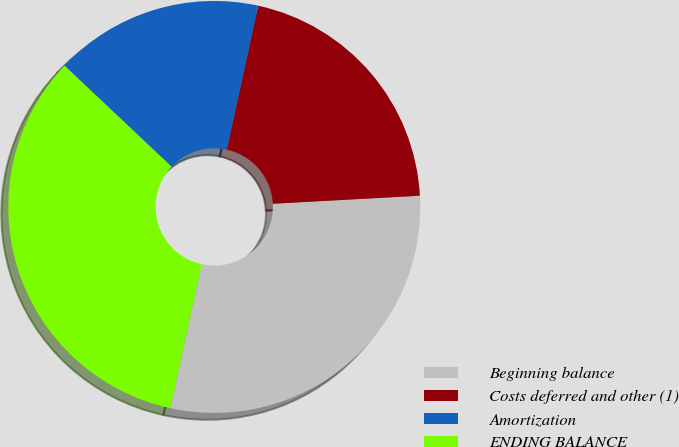<chart> <loc_0><loc_0><loc_500><loc_500><pie_chart><fcel>Beginning balance<fcel>Costs deferred and other (1)<fcel>Amortization<fcel>ENDING BALANCE<nl><fcel>29.29%<fcel>20.71%<fcel>16.38%<fcel>33.62%<nl></chart> 